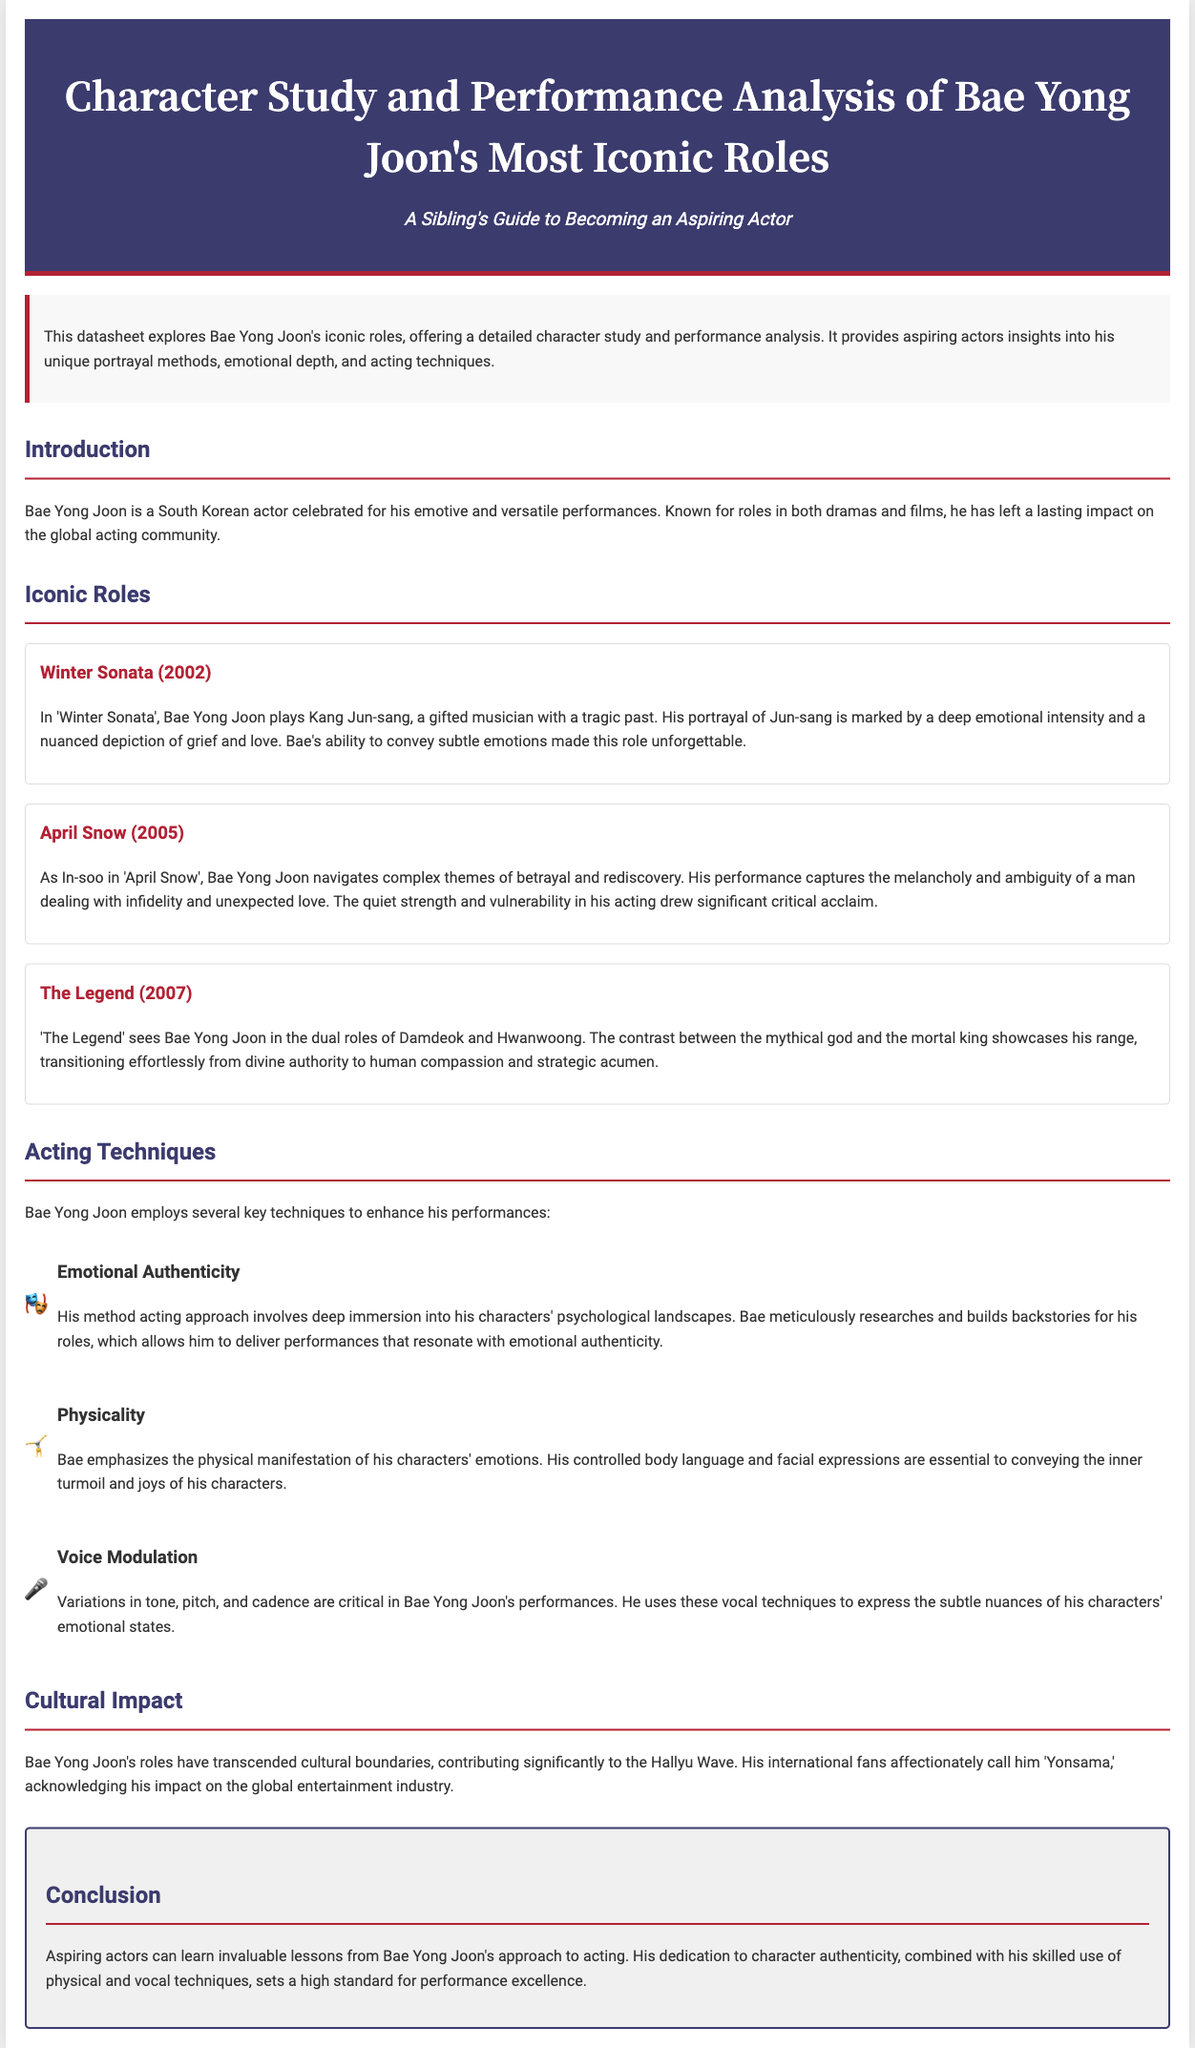What is Bae Yong Joon's character in Winter Sonata? Bae Yong Joon plays Kang Jun-sang in Winter Sonata, a gifted musician with a tragic past.
Answer: Kang Jun-sang What year was April Snow released? April Snow was released in 2005, as stated in the document.
Answer: 2005 How does Bae Yong Joon depict the character In-soo? His performance as In-soo captures themes of betrayal and rediscovery.
Answer: Betrayal and rediscovery What are the two characters played by Bae Yong Joon in The Legend? He plays the roles of Damdeok and Hwanwoong in The Legend.
Answer: Damdeok and Hwanwoong What acting technique emphasizes the physical manifestation of emotions? Bae Yong Joon emphasizes physicality to convey emotions in his performances.
Answer: Physicality How does Bae Yong Joon's global fanbase refer to him? His international fans affectionately call him 'Yonsama.'
Answer: Yonsama What is the subtitle of the datasheet? The subtitle of the datasheet is "A Sibling's Guide to Becoming an Aspiring Actor."
Answer: A Sibling's Guide to Becoming an Aspiring Actor Which technique involves voice variations? Voice modulation is the technique that involves variations in tone, pitch, and cadence.
Answer: Voice modulation 